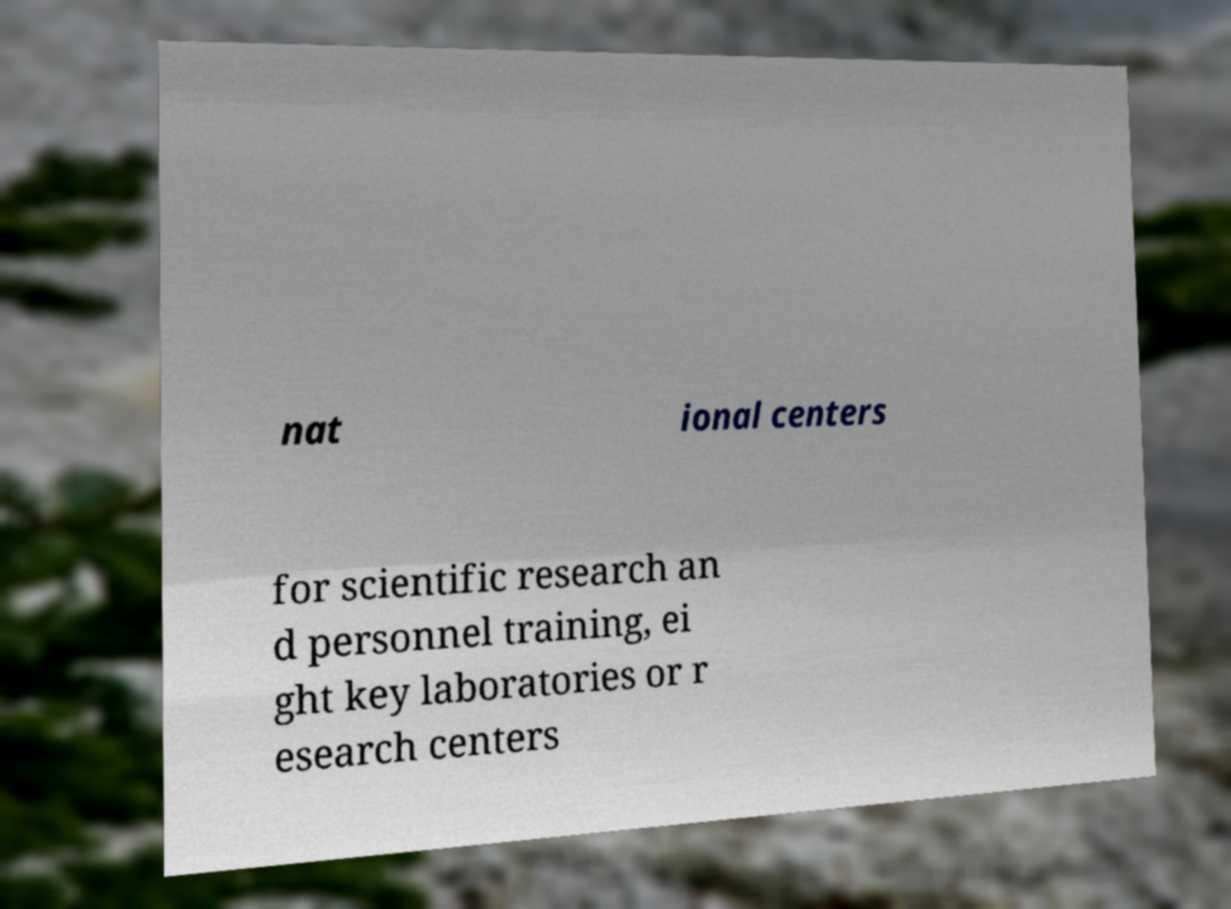Please read and relay the text visible in this image. What does it say? nat ional centers for scientific research an d personnel training, ei ght key laboratories or r esearch centers 